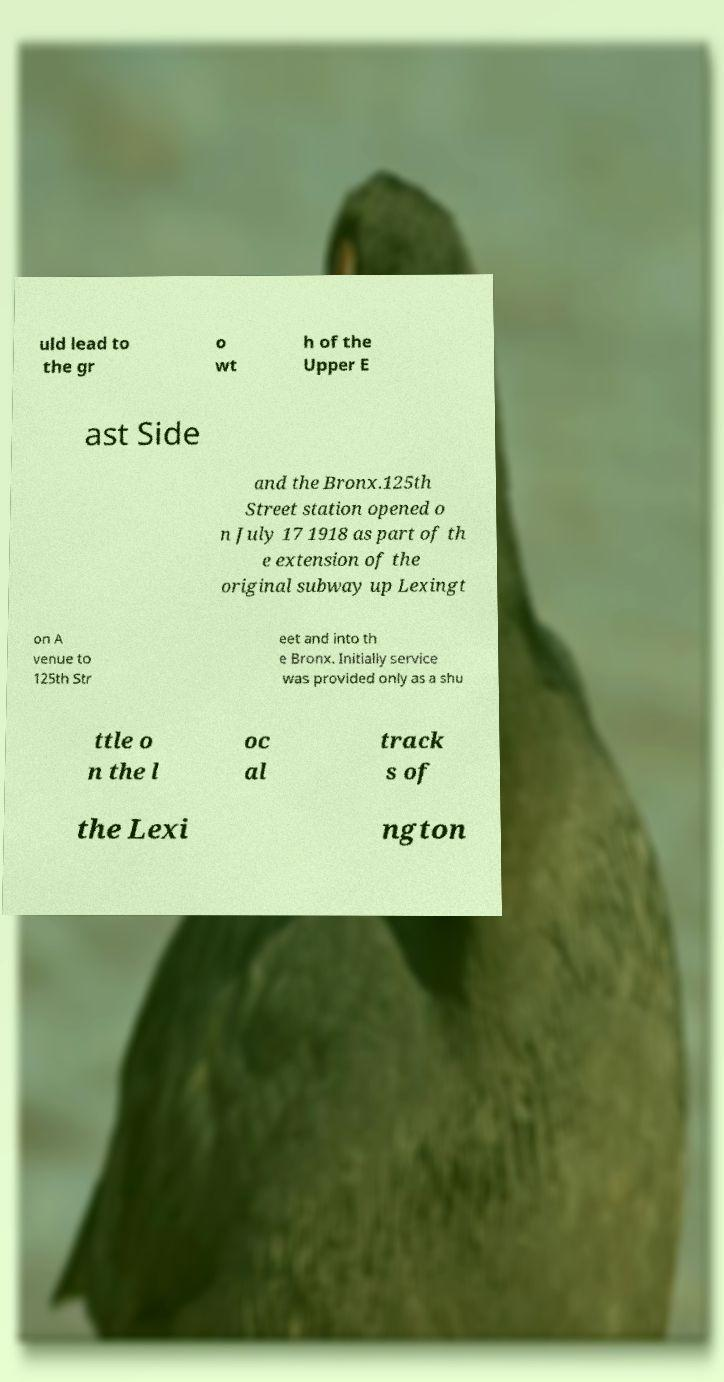What messages or text are displayed in this image? I need them in a readable, typed format. uld lead to the gr o wt h of the Upper E ast Side and the Bronx.125th Street station opened o n July 17 1918 as part of th e extension of the original subway up Lexingt on A venue to 125th Str eet and into th e Bronx. Initially service was provided only as a shu ttle o n the l oc al track s of the Lexi ngton 